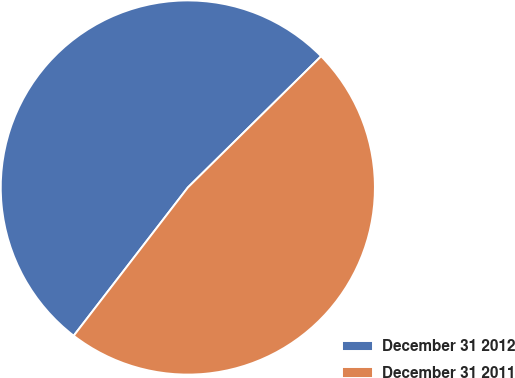Convert chart. <chart><loc_0><loc_0><loc_500><loc_500><pie_chart><fcel>December 31 2012<fcel>December 31 2011<nl><fcel>52.18%<fcel>47.82%<nl></chart> 